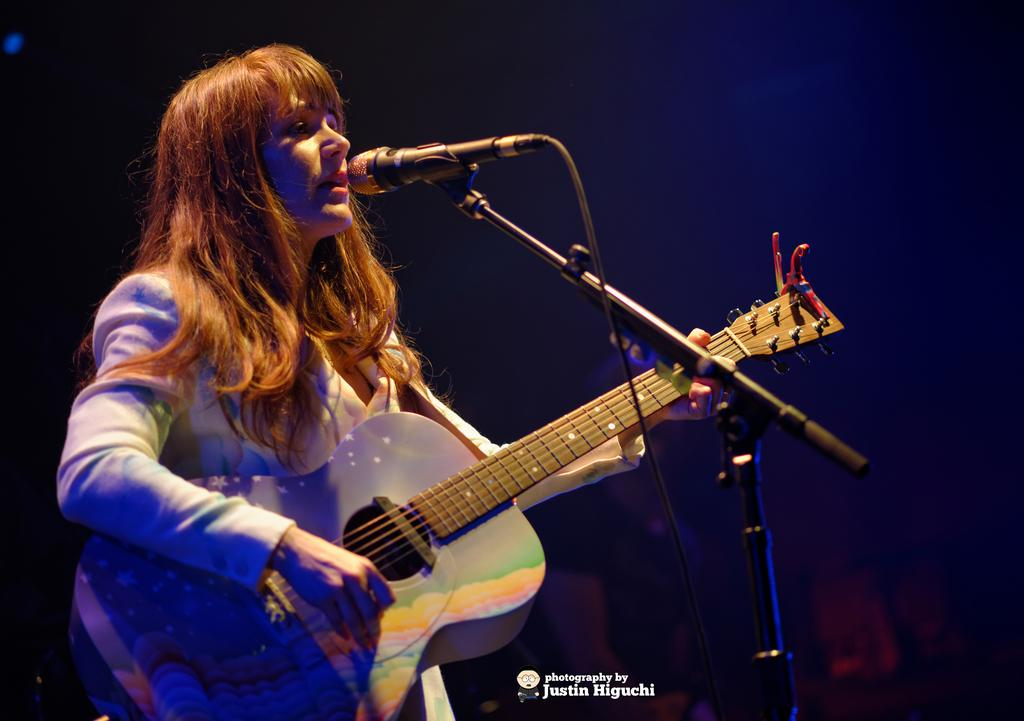Who is the main subject in the image? There is a woman in the image. What is the woman doing in the image? The woman is playing a guitar. What equipment is set up in front of the woman? There is a microphone with a stand in front of the woman. What can be inferred about the lighting conditions in the image? The background of the image is dark. Can you see any mint plants growing near the seashore in the image? There is no seashore or mint plants present in the image. What word is the woman singing in the image? The image does not provide any information about the words being sung by the woman. 